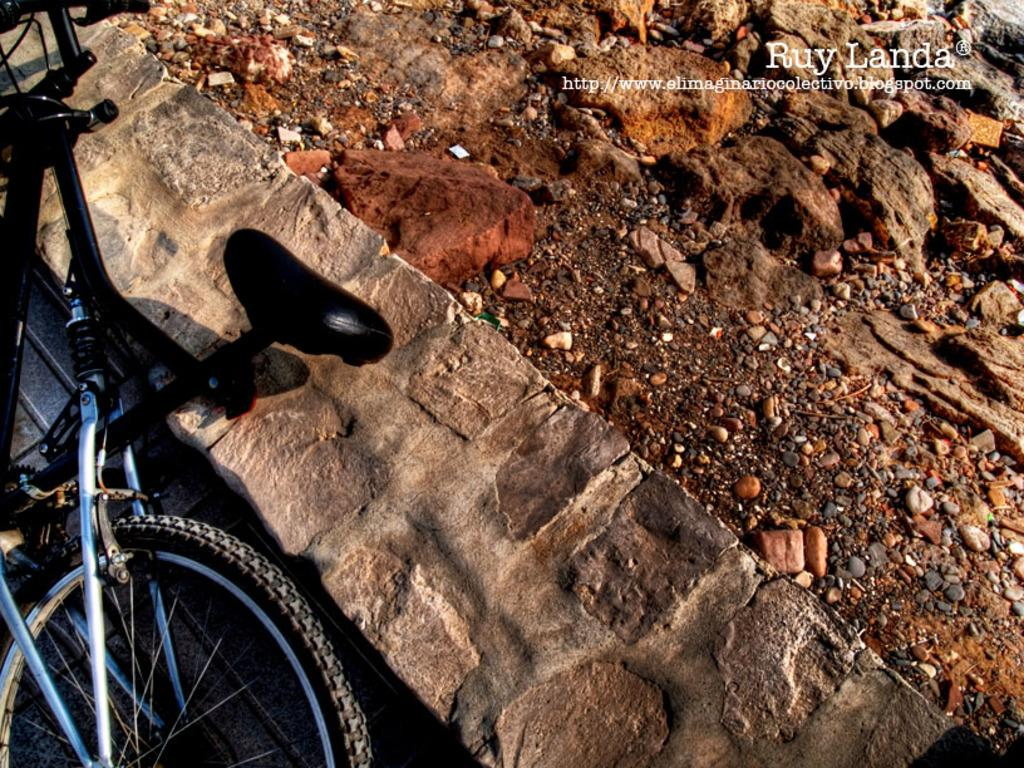What can be seen on the left side of the image? There is a bicycle on the left side of the image. What is the position of the bicycle in the image? The bicycle is lying on the floor. What type of terrain is visible on the right side of the image? There is a land with stones on the right side of the image. What is the taste of the stones on the right side of the image? There is no taste associated with the stones in the image, as they are not edible. 